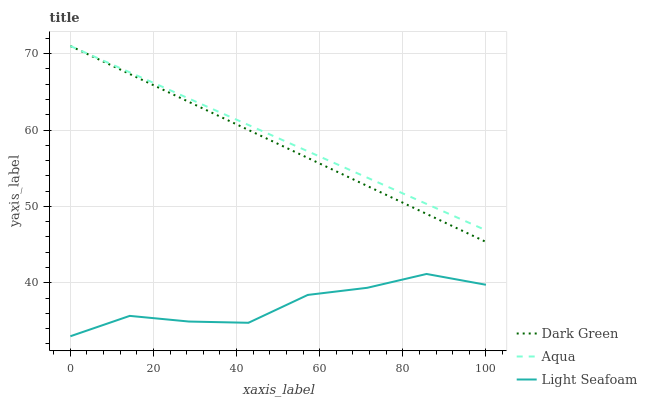Does Light Seafoam have the minimum area under the curve?
Answer yes or no. Yes. Does Aqua have the maximum area under the curve?
Answer yes or no. Yes. Does Dark Green have the minimum area under the curve?
Answer yes or no. No. Does Dark Green have the maximum area under the curve?
Answer yes or no. No. Is Aqua the smoothest?
Answer yes or no. Yes. Is Light Seafoam the roughest?
Answer yes or no. Yes. Is Dark Green the smoothest?
Answer yes or no. No. Is Dark Green the roughest?
Answer yes or no. No. Does Light Seafoam have the lowest value?
Answer yes or no. Yes. Does Dark Green have the lowest value?
Answer yes or no. No. Does Dark Green have the highest value?
Answer yes or no. Yes. Is Light Seafoam less than Aqua?
Answer yes or no. Yes. Is Aqua greater than Light Seafoam?
Answer yes or no. Yes. Does Aqua intersect Dark Green?
Answer yes or no. Yes. Is Aqua less than Dark Green?
Answer yes or no. No. Is Aqua greater than Dark Green?
Answer yes or no. No. Does Light Seafoam intersect Aqua?
Answer yes or no. No. 